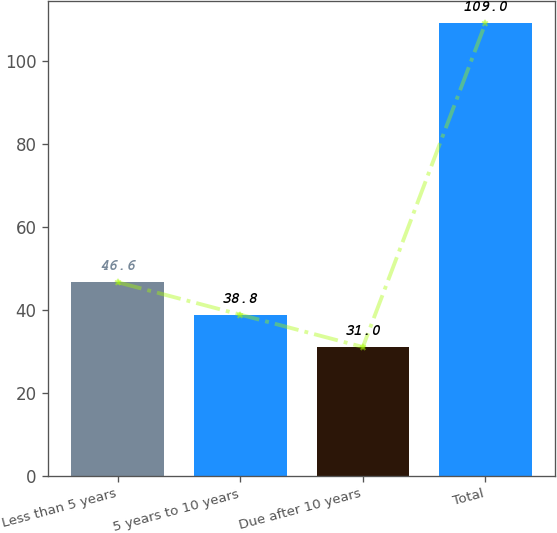<chart> <loc_0><loc_0><loc_500><loc_500><bar_chart><fcel>Less than 5 years<fcel>5 years to 10 years<fcel>Due after 10 years<fcel>Total<nl><fcel>46.6<fcel>38.8<fcel>31<fcel>109<nl></chart> 